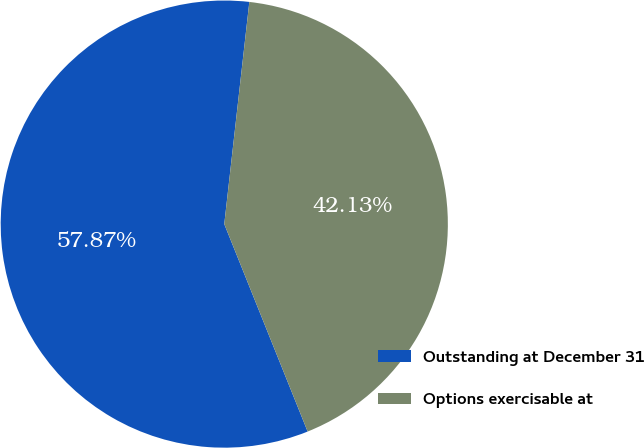Convert chart to OTSL. <chart><loc_0><loc_0><loc_500><loc_500><pie_chart><fcel>Outstanding at December 31<fcel>Options exercisable at<nl><fcel>57.87%<fcel>42.13%<nl></chart> 